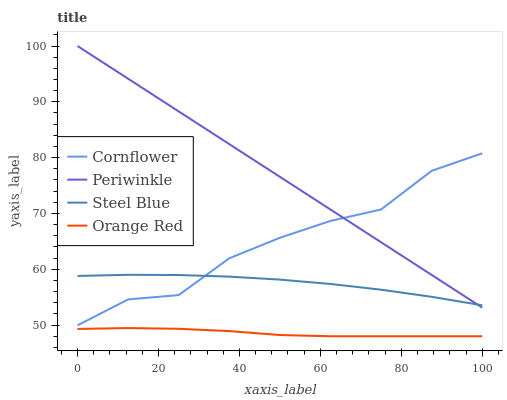Does Orange Red have the minimum area under the curve?
Answer yes or no. Yes. Does Periwinkle have the maximum area under the curve?
Answer yes or no. Yes. Does Steel Blue have the minimum area under the curve?
Answer yes or no. No. Does Steel Blue have the maximum area under the curve?
Answer yes or no. No. Is Periwinkle the smoothest?
Answer yes or no. Yes. Is Cornflower the roughest?
Answer yes or no. Yes. Is Steel Blue the smoothest?
Answer yes or no. No. Is Steel Blue the roughest?
Answer yes or no. No. Does Periwinkle have the lowest value?
Answer yes or no. No. Does Periwinkle have the highest value?
Answer yes or no. Yes. Does Steel Blue have the highest value?
Answer yes or no. No. Is Orange Red less than Steel Blue?
Answer yes or no. Yes. Is Cornflower greater than Orange Red?
Answer yes or no. Yes. Does Cornflower intersect Steel Blue?
Answer yes or no. Yes. Is Cornflower less than Steel Blue?
Answer yes or no. No. Is Cornflower greater than Steel Blue?
Answer yes or no. No. Does Orange Red intersect Steel Blue?
Answer yes or no. No. 